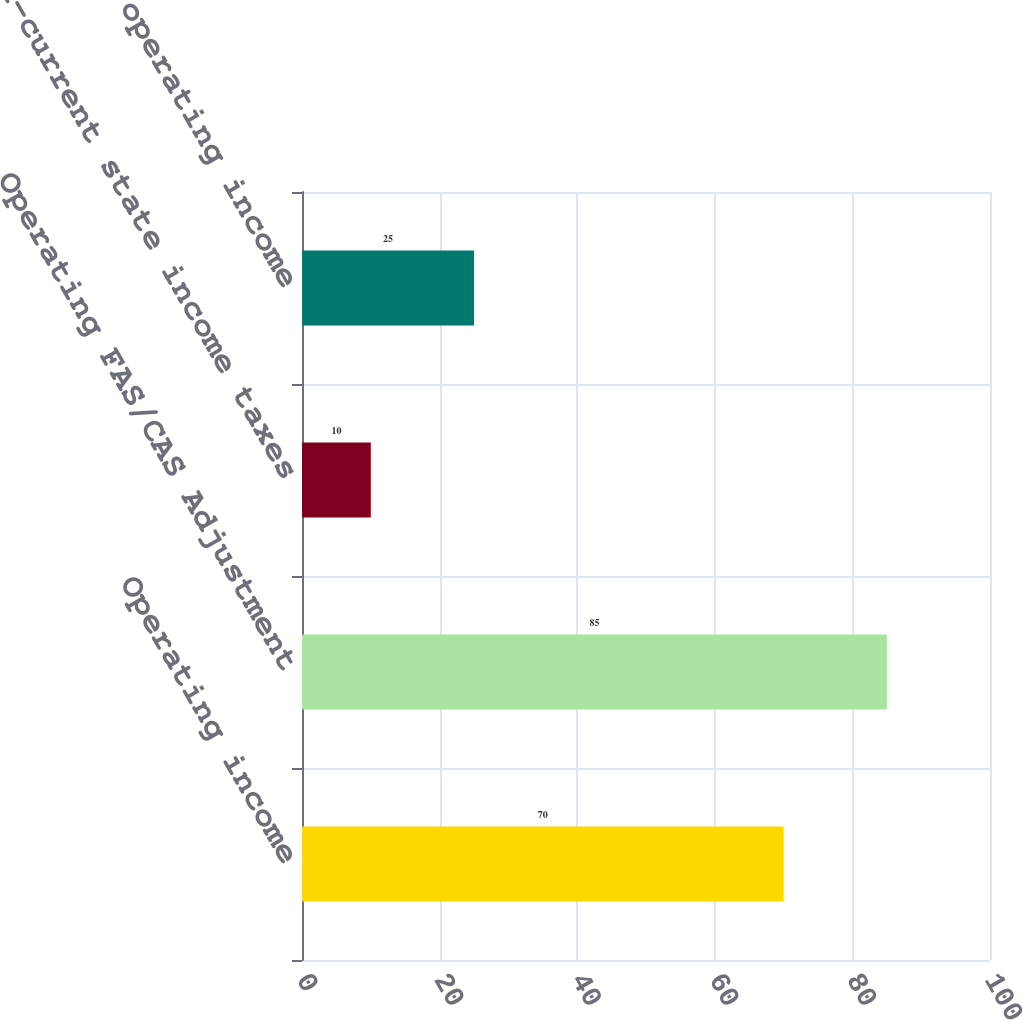<chart> <loc_0><loc_0><loc_500><loc_500><bar_chart><fcel>Operating income<fcel>Operating FAS/CAS Adjustment<fcel>Non-current state income taxes<fcel>Segment operating income<nl><fcel>70<fcel>85<fcel>10<fcel>25<nl></chart> 